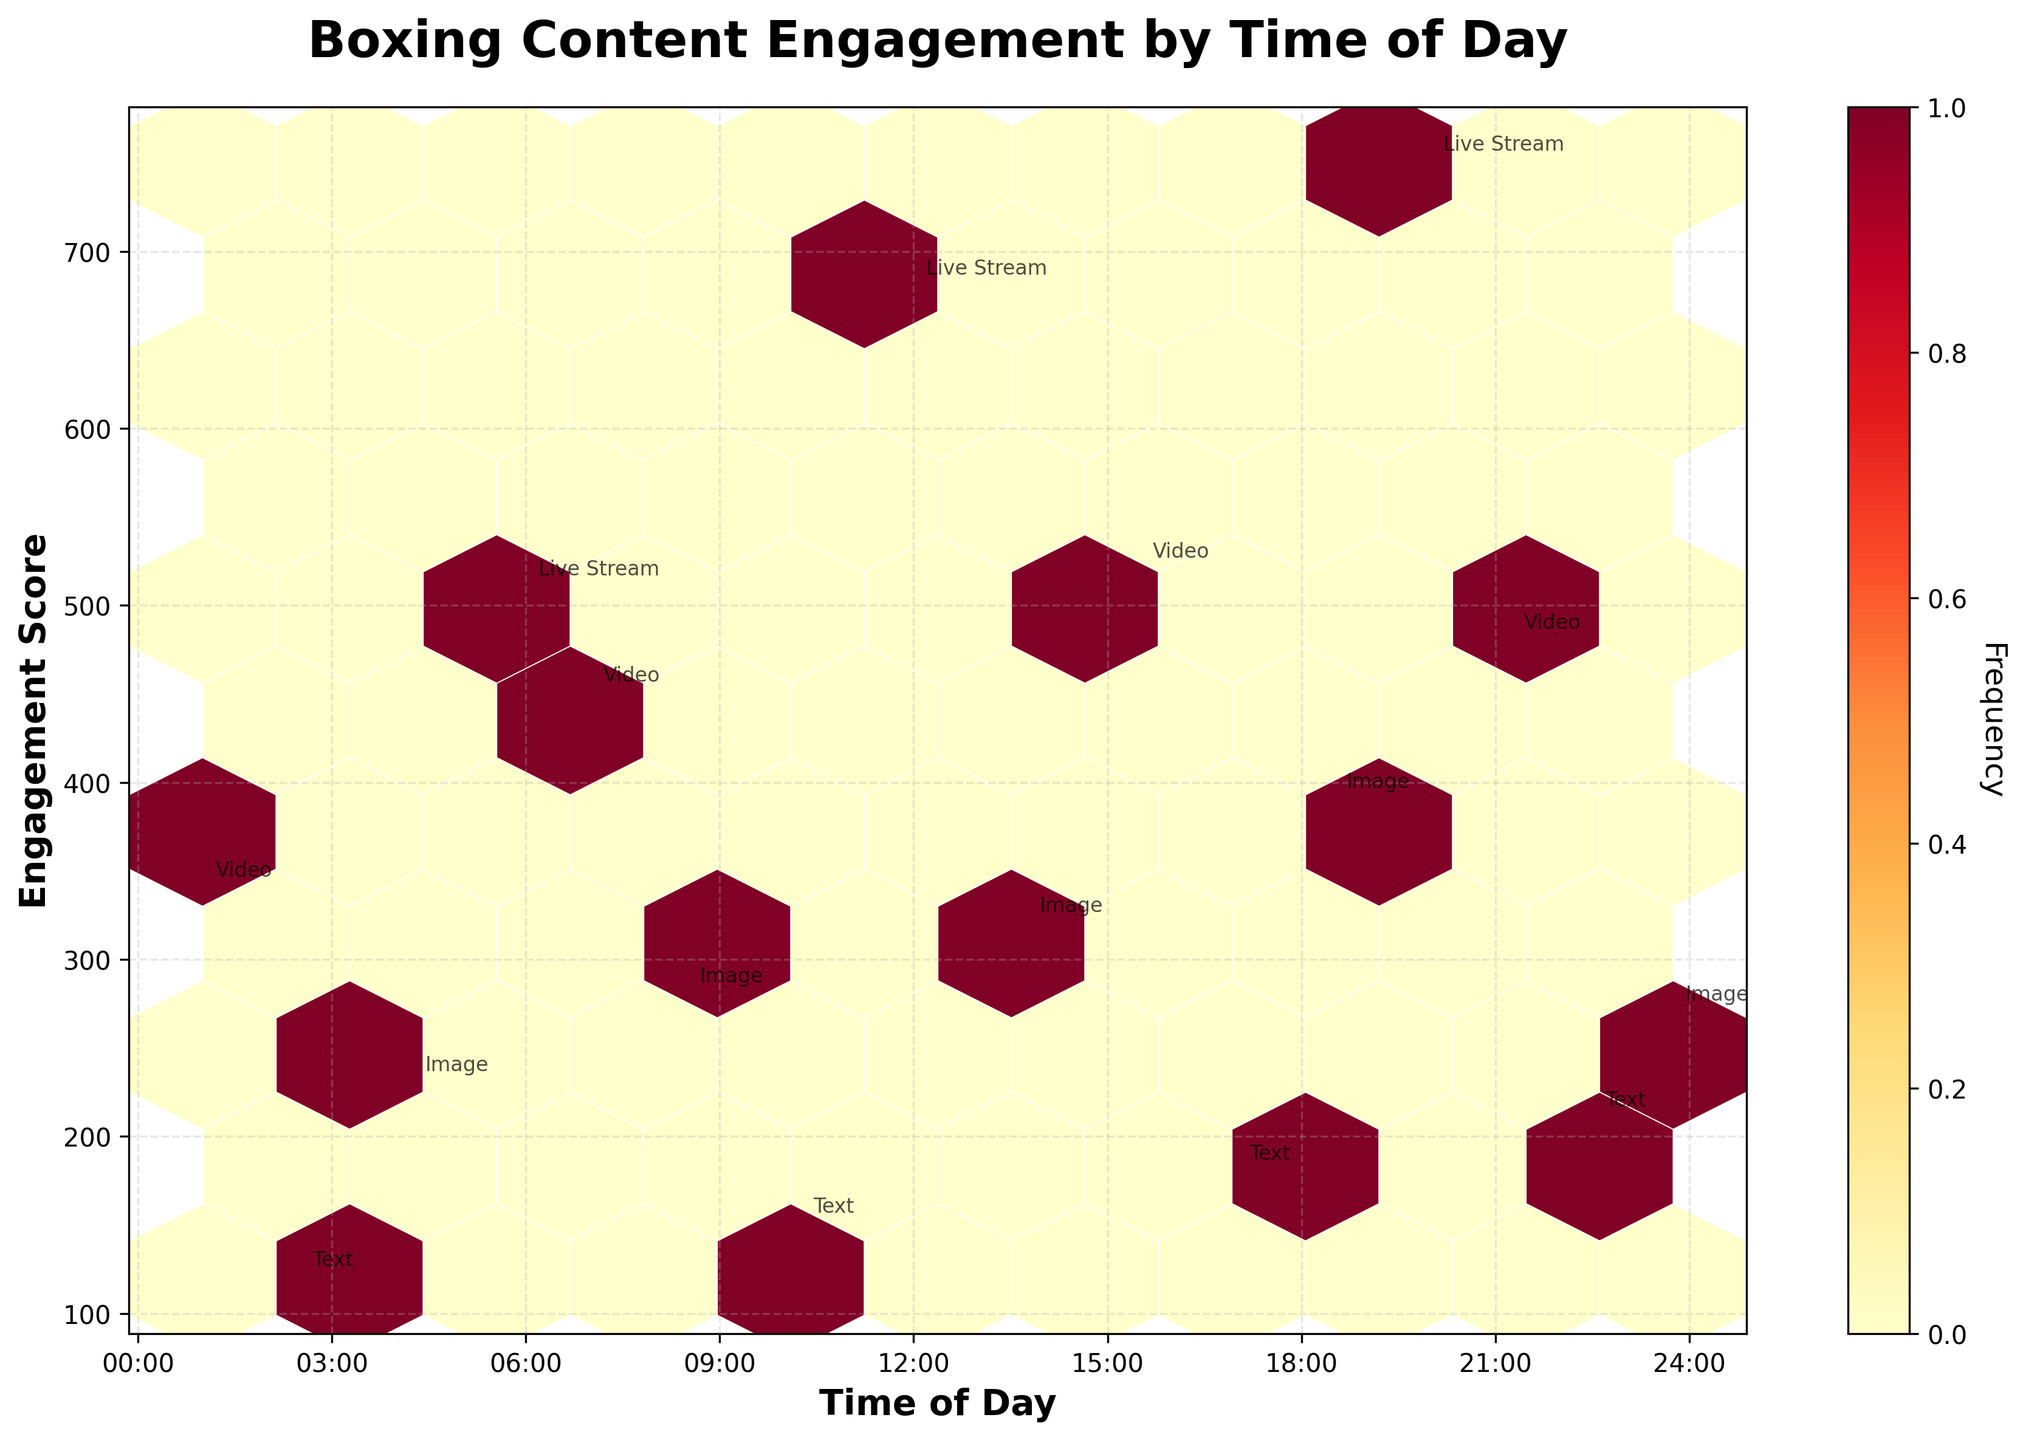What is the title of the plot? The title of the plot is located at the top and provides an overview of the figure. It reads "Boxing Content Engagement by Time of Day."
Answer: Boxing Content Engagement by Time of Day Which post type shows up most frequently around 18:30? By looking at the annotations around 18:30 on the x-axis, the post type "Image" appears at that time with an Engagement Score of 390.
Answer: Image Which time of day has the highest engagement score? The highest engagement score can be found by looking at the y-axis and locating the highest point annotated. The highest score is 750, occurring at 20:00.
Answer: 20:00 How does the engagement score for videos around 15:30 compare to that around 07:00? We observe the "Video" annotations around these times. At 15:30, the engagement score is 520, while at 07:00, the score is 450. 520 is greater than 450.
Answer: 15:30 has a higher score Is there a time period where 'Live Stream' posts tend to have high engagement? We identify the 'Live Stream' annotations and their corresponding engagement scores. They occur at 12:00 (680), 20:00 (750), and 06:00 (510), which are all relatively high.
Answer: Morning and Night Compare the engagement of posts mentioning 'Anthony Joshua' vs. 'Tyson Fury'. The scores for 'Anthony Joshua' are 450, 680, 520, 390, 480, 270, and 230. For 'Tyson Fury', the scores are 280 and 750. Summing them gives Anthony Joshua: 3020 and Tyson Fury: 1030.
Answer: Anthony Joshua has higher total engagement What is the average engagement score for posts around 12:00 and 13:45? The scores at 12:00 and 13:45 are 680 and 320, respectively. Their average is (680 + 320) / 2 = 500.
Answer: 500 Are there any post types that consistently have low engagement scores? By scanning the annotations and their engagement scores, we see that 'Text' posts have scores like 150, 180, 210, and 120, which are consistently below those of other types.
Answer: Text posts How does the engagement for posts mentioning 'Canelo Alvarez' around 01:00 compare to posts mentioning 'Canelo Alvarez' at 10:15? Look at the engagement scores: 340 at 01:00 vs. 150 at 10:15. 340 is higher than 150.
Answer: 01:00 has higher engagement What is the range of engagement scores for 'Image' posts throughout the day? The scores for 'Image' posts at different times are 280, 320, 390, 270, and 230. The range is calculated as the difference between the highest (390) and lowest (230) scores. So, 390 - 230 = 160.
Answer: 160 